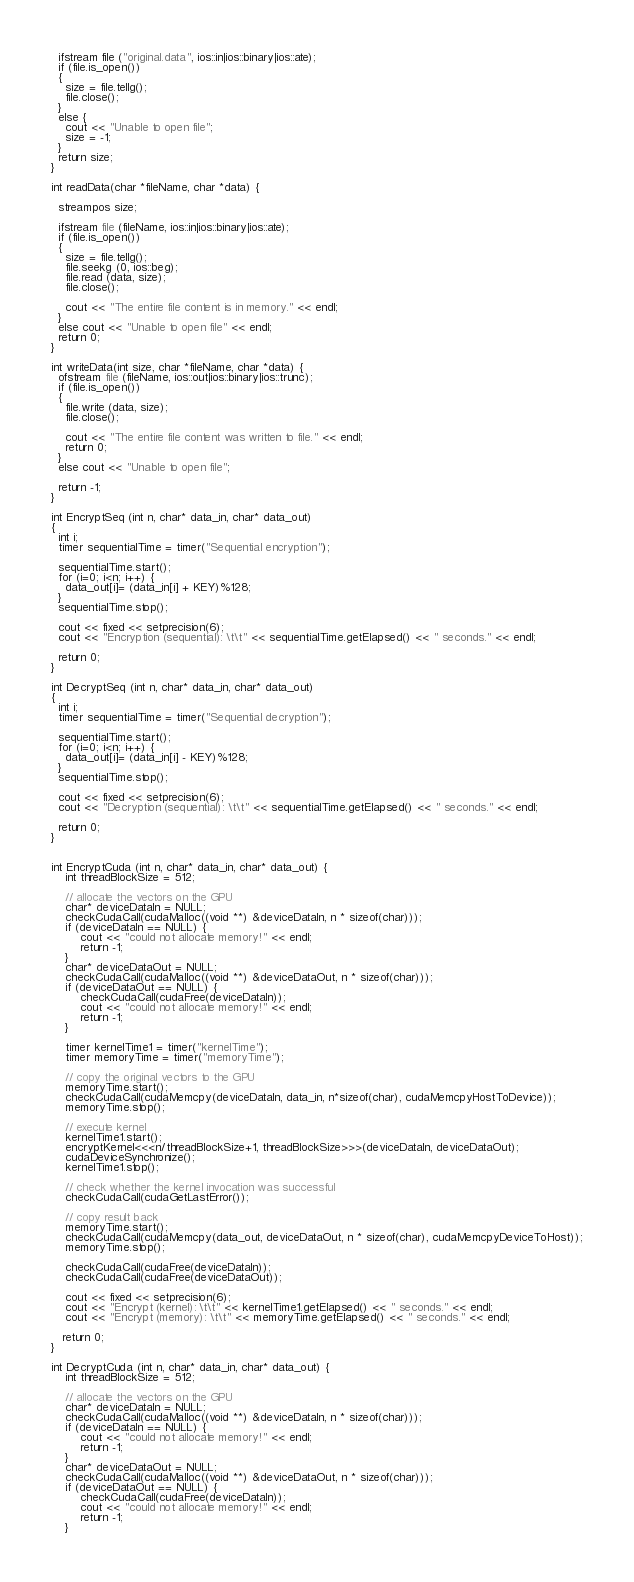Convert code to text. <code><loc_0><loc_0><loc_500><loc_500><_Cuda_>  ifstream file ("original.data", ios::in|ios::binary|ios::ate);
  if (file.is_open())
  {
    size = file.tellg();
    file.close();
  }
  else {
    cout << "Unable to open file";
    size = -1;
  }
  return size;
}

int readData(char *fileName, char *data) {

  streampos size;

  ifstream file (fileName, ios::in|ios::binary|ios::ate);
  if (file.is_open())
  {
    size = file.tellg();
    file.seekg (0, ios::beg);
    file.read (data, size);
    file.close();

    cout << "The entire file content is in memory." << endl;
  }
  else cout << "Unable to open file" << endl;
  return 0;
}

int writeData(int size, char *fileName, char *data) {
  ofstream file (fileName, ios::out|ios::binary|ios::trunc);
  if (file.is_open())
  {
    file.write (data, size);
    file.close();

    cout << "The entire file content was written to file." << endl;
    return 0;
  }
  else cout << "Unable to open file";

  return -1;
}

int EncryptSeq (int n, char* data_in, char* data_out)
{
  int i;
  timer sequentialTime = timer("Sequential encryption");

  sequentialTime.start();
  for (i=0; i<n; i++) {
    data_out[i]= (data_in[i] + KEY)%128;
  }
  sequentialTime.stop();

  cout << fixed << setprecision(6);
  cout << "Encryption (sequential): \t\t" << sequentialTime.getElapsed() << " seconds." << endl;

  return 0;
}

int DecryptSeq (int n, char* data_in, char* data_out)
{
  int i;
  timer sequentialTime = timer("Sequential decryption");

  sequentialTime.start();
  for (i=0; i<n; i++) {
    data_out[i]= (data_in[i] - KEY)%128;
  }
  sequentialTime.stop();

  cout << fixed << setprecision(6);
  cout << "Decryption (sequential): \t\t" << sequentialTime.getElapsed() << " seconds." << endl;

  return 0;
}


int EncryptCuda (int n, char* data_in, char* data_out) {
    int threadBlockSize = 512;

    // allocate the vectors on the GPU
    char* deviceDataIn = NULL;
    checkCudaCall(cudaMalloc((void **) &deviceDataIn, n * sizeof(char)));
    if (deviceDataIn == NULL) {
        cout << "could not allocate memory!" << endl;
        return -1;
    }
    char* deviceDataOut = NULL;
    checkCudaCall(cudaMalloc((void **) &deviceDataOut, n * sizeof(char)));
    if (deviceDataOut == NULL) {
        checkCudaCall(cudaFree(deviceDataIn));
        cout << "could not allocate memory!" << endl;
        return -1;
    }

    timer kernelTime1 = timer("kernelTime");
    timer memoryTime = timer("memoryTime");

    // copy the original vectors to the GPU
    memoryTime.start();
    checkCudaCall(cudaMemcpy(deviceDataIn, data_in, n*sizeof(char), cudaMemcpyHostToDevice));
    memoryTime.stop();

    // execute kernel
    kernelTime1.start();
    encryptKernel<<<n/threadBlockSize+1, threadBlockSize>>>(deviceDataIn, deviceDataOut);
    cudaDeviceSynchronize();
    kernelTime1.stop();

    // check whether the kernel invocation was successful
    checkCudaCall(cudaGetLastError());

    // copy result back
    memoryTime.start();
    checkCudaCall(cudaMemcpy(data_out, deviceDataOut, n * sizeof(char), cudaMemcpyDeviceToHost));
    memoryTime.stop();

    checkCudaCall(cudaFree(deviceDataIn));
    checkCudaCall(cudaFree(deviceDataOut));

    cout << fixed << setprecision(6);
    cout << "Encrypt (kernel): \t\t" << kernelTime1.getElapsed() << " seconds." << endl;
    cout << "Encrypt (memory): \t\t" << memoryTime.getElapsed() << " seconds." << endl;

   return 0;
}

int DecryptCuda (int n, char* data_in, char* data_out) {
    int threadBlockSize = 512;

    // allocate the vectors on the GPU
    char* deviceDataIn = NULL;
    checkCudaCall(cudaMalloc((void **) &deviceDataIn, n * sizeof(char)));
    if (deviceDataIn == NULL) {
        cout << "could not allocate memory!" << endl;
        return -1;
    }
    char* deviceDataOut = NULL;
    checkCudaCall(cudaMalloc((void **) &deviceDataOut, n * sizeof(char)));
    if (deviceDataOut == NULL) {
        checkCudaCall(cudaFree(deviceDataIn));
        cout << "could not allocate memory!" << endl;
        return -1;
    }
</code> 